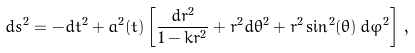Convert formula to latex. <formula><loc_0><loc_0><loc_500><loc_500>d s ^ { 2 } = - d t ^ { 2 } + a ^ { 2 } ( t ) \left [ \frac { d r ^ { 2 } } { 1 - k r ^ { 2 } } + r ^ { 2 } d \theta ^ { 2 } + r ^ { 2 } \sin ^ { 2 } ( \theta ) \, d \varphi ^ { 2 } \right ] \, ,</formula> 